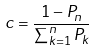<formula> <loc_0><loc_0><loc_500><loc_500>c = \frac { 1 - P _ { n } } { \sum _ { k = 1 } ^ { n } P _ { k } }</formula> 